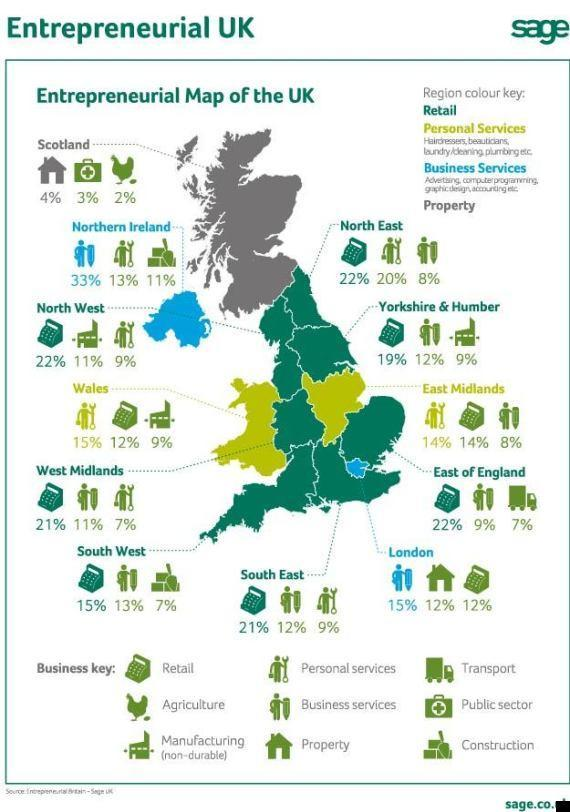What percentage of people in Scotland are agro entrepreneurs?
Answer the question with a short phrase. 2% In which regions of UK, construction entrepreneurs are available? Northern Ireland, South West What percentage of people in London are property entrepreneurs? 15% What percentage of people in Wales are retail entrepreneurs? 12% In which regions of UK, entrepreneurship in business services are seen? Northern Ireland, London Which is the only country in UK having agro entrepreneurs? Scotland 